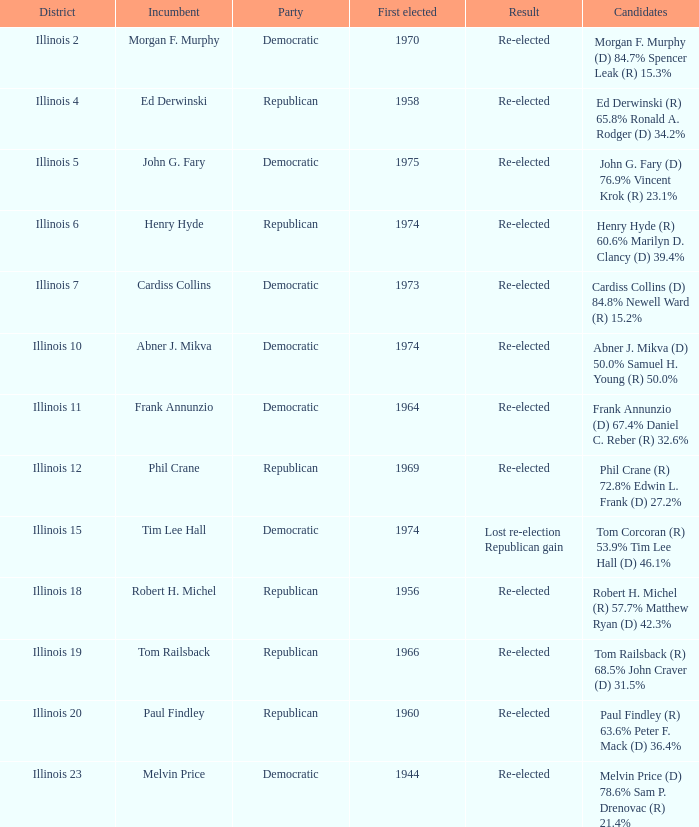Name the total number of incumbent for first elected of 1944 1.0. 